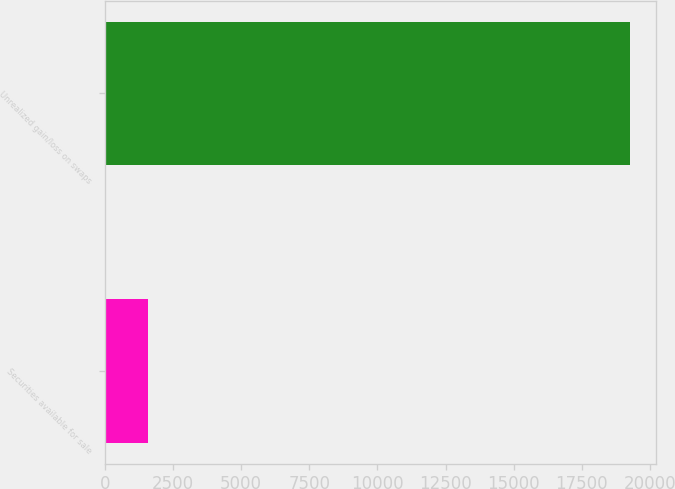Convert chart to OTSL. <chart><loc_0><loc_0><loc_500><loc_500><bar_chart><fcel>Securities available for sale<fcel>Unrealized gain/loss on swaps<nl><fcel>1575<fcel>19252<nl></chart> 